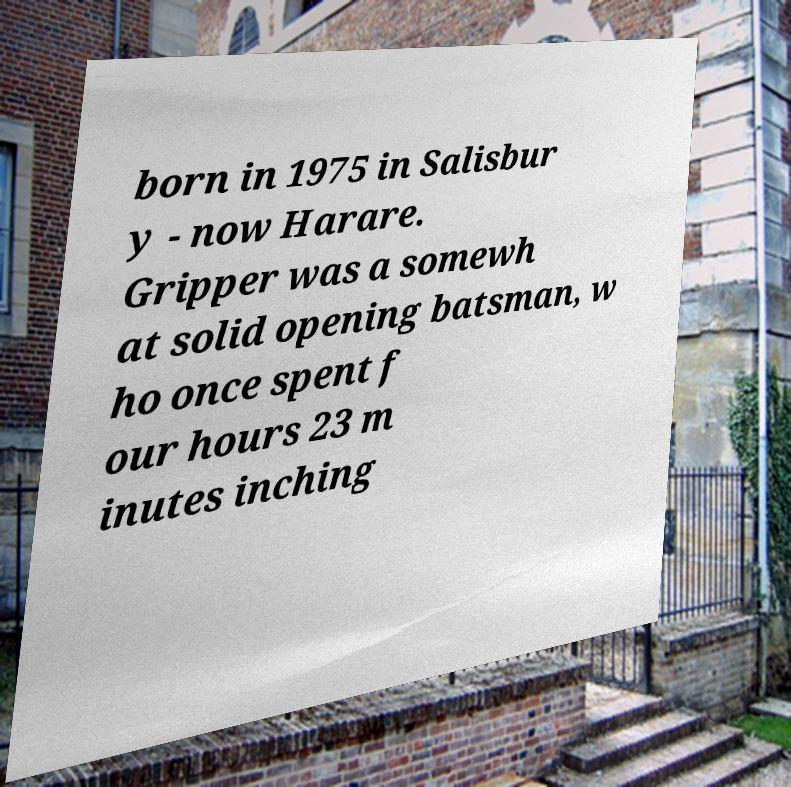Could you assist in decoding the text presented in this image and type it out clearly? born in 1975 in Salisbur y - now Harare. Gripper was a somewh at solid opening batsman, w ho once spent f our hours 23 m inutes inching 